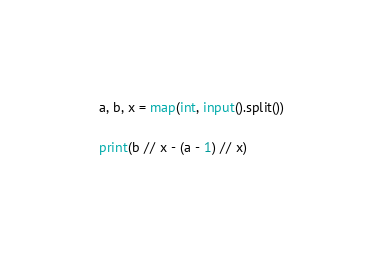Convert code to text. <code><loc_0><loc_0><loc_500><loc_500><_Python_>a, b, x = map(int, input().split())

print(b // x - (a - 1) // x)</code> 